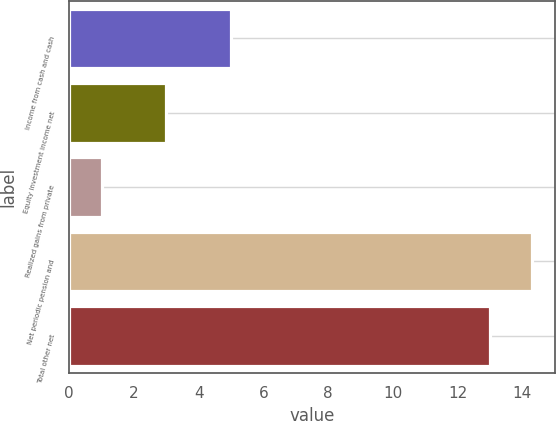<chart> <loc_0><loc_0><loc_500><loc_500><bar_chart><fcel>Income from cash and cash<fcel>Equity investment income net<fcel>Realized gains from private<fcel>Net periodic pension and<fcel>Total other net<nl><fcel>5<fcel>3<fcel>1<fcel>14.3<fcel>13<nl></chart> 